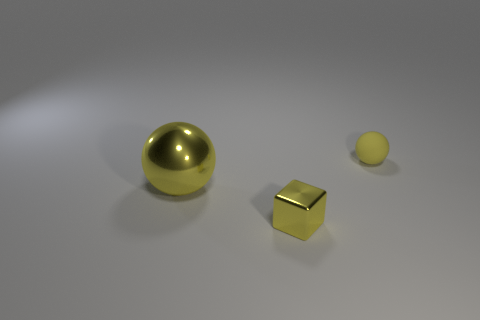Subtract all purple cubes. Subtract all gray cylinders. How many cubes are left? 1 Add 3 yellow balls. How many objects exist? 6 Subtract all balls. How many objects are left? 1 Subtract 0 blue cubes. How many objects are left? 3 Subtract all big purple rubber balls. Subtract all large yellow shiny balls. How many objects are left? 2 Add 3 small yellow matte objects. How many small yellow matte objects are left? 4 Add 1 yellow matte spheres. How many yellow matte spheres exist? 2 